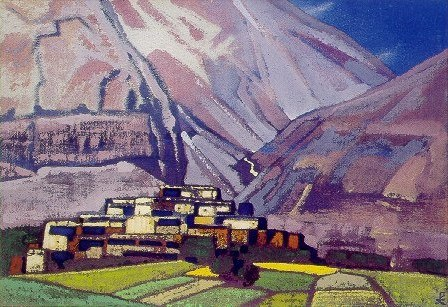Explain the visual content of the image in great detail. The image is a vibrant representation of an impressionistic landscape. The foreground is dominated by a quaint village, characterized by white buildings topped with orange roofs. The village is nestled amidst a lush expanse of greenery, which is painted in bold strokes of green and blue. The background is adorned with majestic mountains, their grandeur captured in hues of blue and purple. The overall art genre of this piece is landscape, and the artist has skillfully used a palette of predominantly blue, green, and purple to bring this scene to life. 